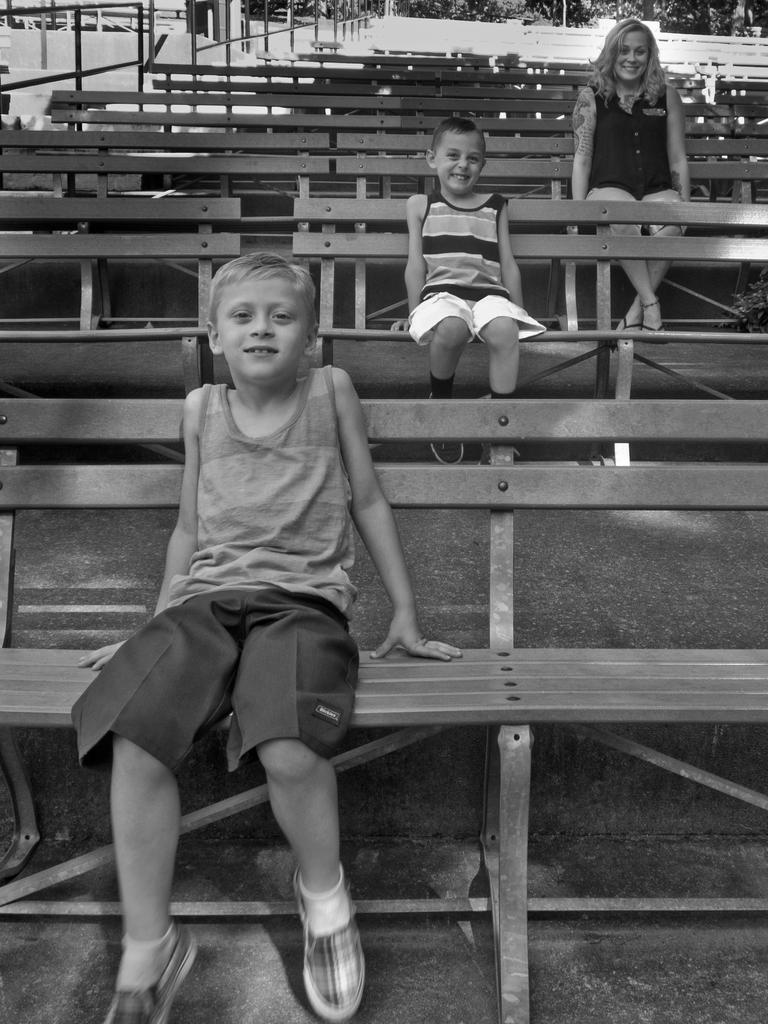What type of seating is visible in the image? There are benches in the image. How are the benches arranged? The benches are placed in a row. What are the people in the image doing? There are persons sitting on the benches. What can be seen in the background of the image? There are trees and an iron grill in the background of the image. What type of cushion is used on the benches in the image? There is no mention of cushions on the benches in the image; they appear to be plain benches. 